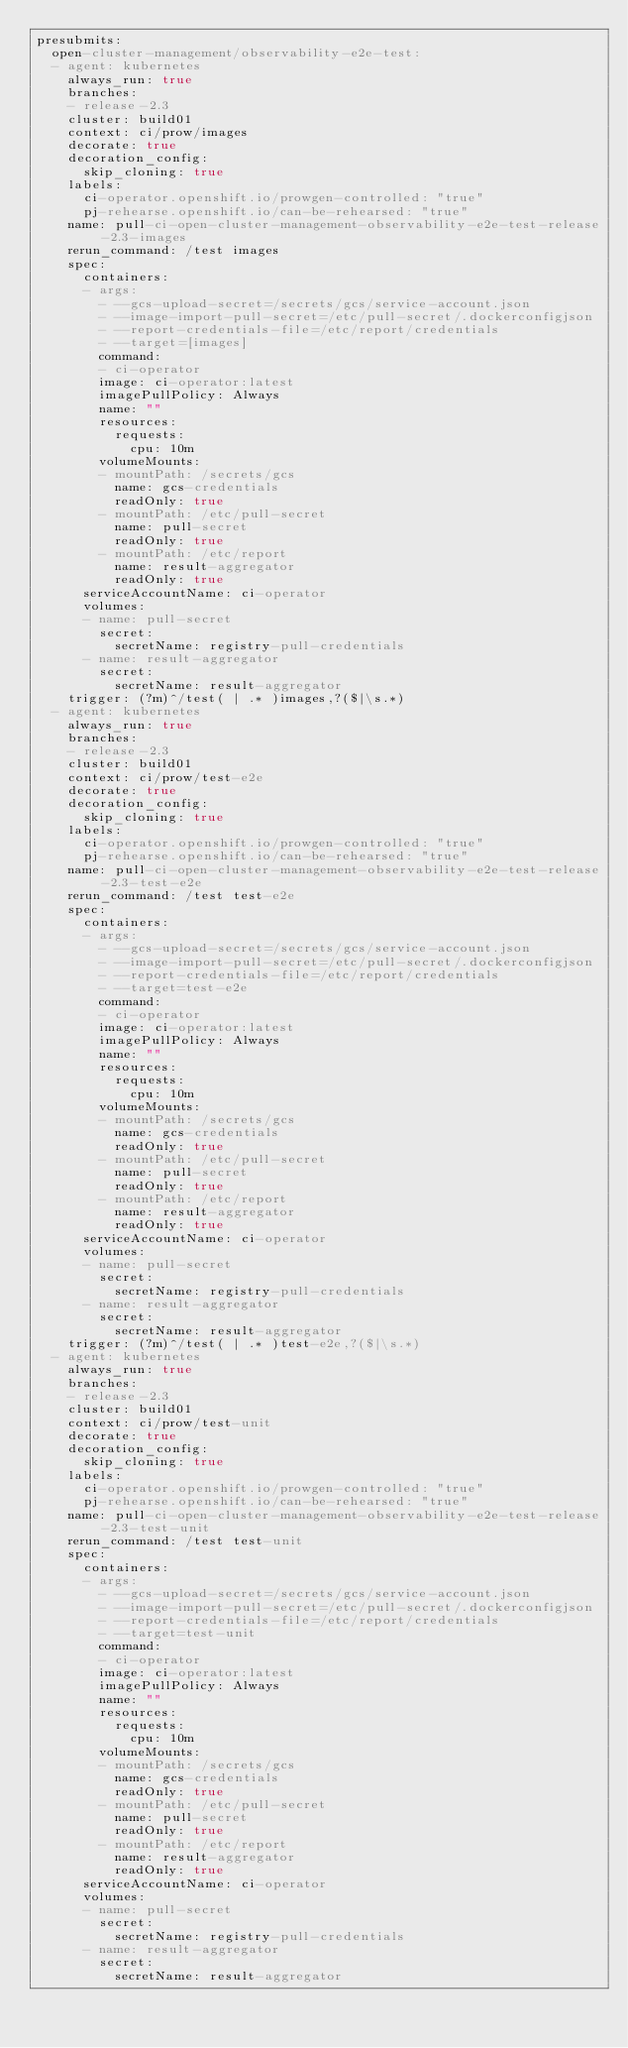Convert code to text. <code><loc_0><loc_0><loc_500><loc_500><_YAML_>presubmits:
  open-cluster-management/observability-e2e-test:
  - agent: kubernetes
    always_run: true
    branches:
    - release-2.3
    cluster: build01
    context: ci/prow/images
    decorate: true
    decoration_config:
      skip_cloning: true
    labels:
      ci-operator.openshift.io/prowgen-controlled: "true"
      pj-rehearse.openshift.io/can-be-rehearsed: "true"
    name: pull-ci-open-cluster-management-observability-e2e-test-release-2.3-images
    rerun_command: /test images
    spec:
      containers:
      - args:
        - --gcs-upload-secret=/secrets/gcs/service-account.json
        - --image-import-pull-secret=/etc/pull-secret/.dockerconfigjson
        - --report-credentials-file=/etc/report/credentials
        - --target=[images]
        command:
        - ci-operator
        image: ci-operator:latest
        imagePullPolicy: Always
        name: ""
        resources:
          requests:
            cpu: 10m
        volumeMounts:
        - mountPath: /secrets/gcs
          name: gcs-credentials
          readOnly: true
        - mountPath: /etc/pull-secret
          name: pull-secret
          readOnly: true
        - mountPath: /etc/report
          name: result-aggregator
          readOnly: true
      serviceAccountName: ci-operator
      volumes:
      - name: pull-secret
        secret:
          secretName: registry-pull-credentials
      - name: result-aggregator
        secret:
          secretName: result-aggregator
    trigger: (?m)^/test( | .* )images,?($|\s.*)
  - agent: kubernetes
    always_run: true
    branches:
    - release-2.3
    cluster: build01
    context: ci/prow/test-e2e
    decorate: true
    decoration_config:
      skip_cloning: true
    labels:
      ci-operator.openshift.io/prowgen-controlled: "true"
      pj-rehearse.openshift.io/can-be-rehearsed: "true"
    name: pull-ci-open-cluster-management-observability-e2e-test-release-2.3-test-e2e
    rerun_command: /test test-e2e
    spec:
      containers:
      - args:
        - --gcs-upload-secret=/secrets/gcs/service-account.json
        - --image-import-pull-secret=/etc/pull-secret/.dockerconfigjson
        - --report-credentials-file=/etc/report/credentials
        - --target=test-e2e
        command:
        - ci-operator
        image: ci-operator:latest
        imagePullPolicy: Always
        name: ""
        resources:
          requests:
            cpu: 10m
        volumeMounts:
        - mountPath: /secrets/gcs
          name: gcs-credentials
          readOnly: true
        - mountPath: /etc/pull-secret
          name: pull-secret
          readOnly: true
        - mountPath: /etc/report
          name: result-aggregator
          readOnly: true
      serviceAccountName: ci-operator
      volumes:
      - name: pull-secret
        secret:
          secretName: registry-pull-credentials
      - name: result-aggregator
        secret:
          secretName: result-aggregator
    trigger: (?m)^/test( | .* )test-e2e,?($|\s.*)
  - agent: kubernetes
    always_run: true
    branches:
    - release-2.3
    cluster: build01
    context: ci/prow/test-unit
    decorate: true
    decoration_config:
      skip_cloning: true
    labels:
      ci-operator.openshift.io/prowgen-controlled: "true"
      pj-rehearse.openshift.io/can-be-rehearsed: "true"
    name: pull-ci-open-cluster-management-observability-e2e-test-release-2.3-test-unit
    rerun_command: /test test-unit
    spec:
      containers:
      - args:
        - --gcs-upload-secret=/secrets/gcs/service-account.json
        - --image-import-pull-secret=/etc/pull-secret/.dockerconfigjson
        - --report-credentials-file=/etc/report/credentials
        - --target=test-unit
        command:
        - ci-operator
        image: ci-operator:latest
        imagePullPolicy: Always
        name: ""
        resources:
          requests:
            cpu: 10m
        volumeMounts:
        - mountPath: /secrets/gcs
          name: gcs-credentials
          readOnly: true
        - mountPath: /etc/pull-secret
          name: pull-secret
          readOnly: true
        - mountPath: /etc/report
          name: result-aggregator
          readOnly: true
      serviceAccountName: ci-operator
      volumes:
      - name: pull-secret
        secret:
          secretName: registry-pull-credentials
      - name: result-aggregator
        secret:
          secretName: result-aggregator</code> 